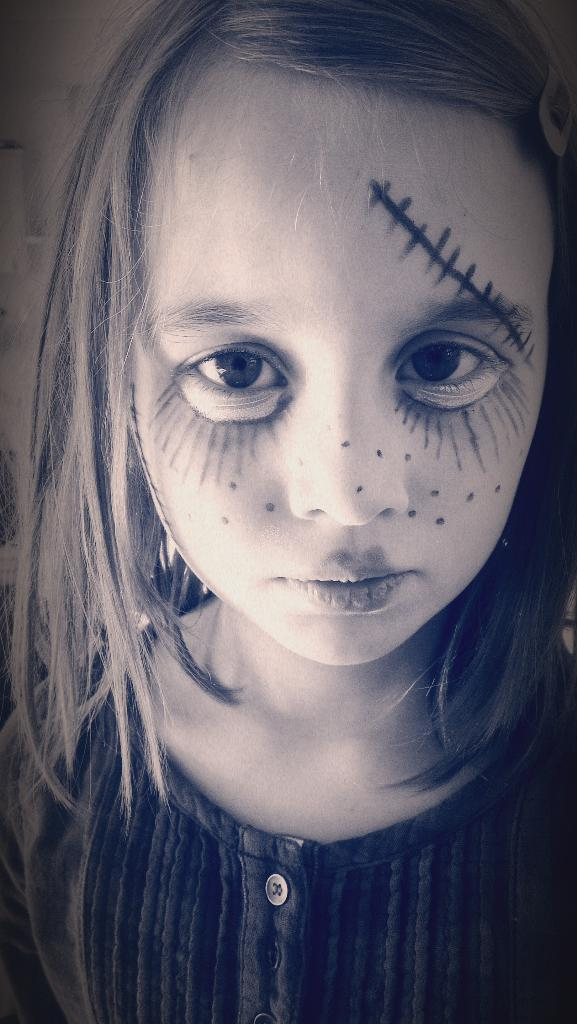Who is the main subject in the image? There is a girl in the image. What can be observed about the girl's appearance? The girl has a painted face. Where is the girl positioned in the image? The girl is in the center of the image. What type of vest is the girl wearing in the image? There is no mention of a vest in the image, so it cannot be determined if the girl is wearing one. 